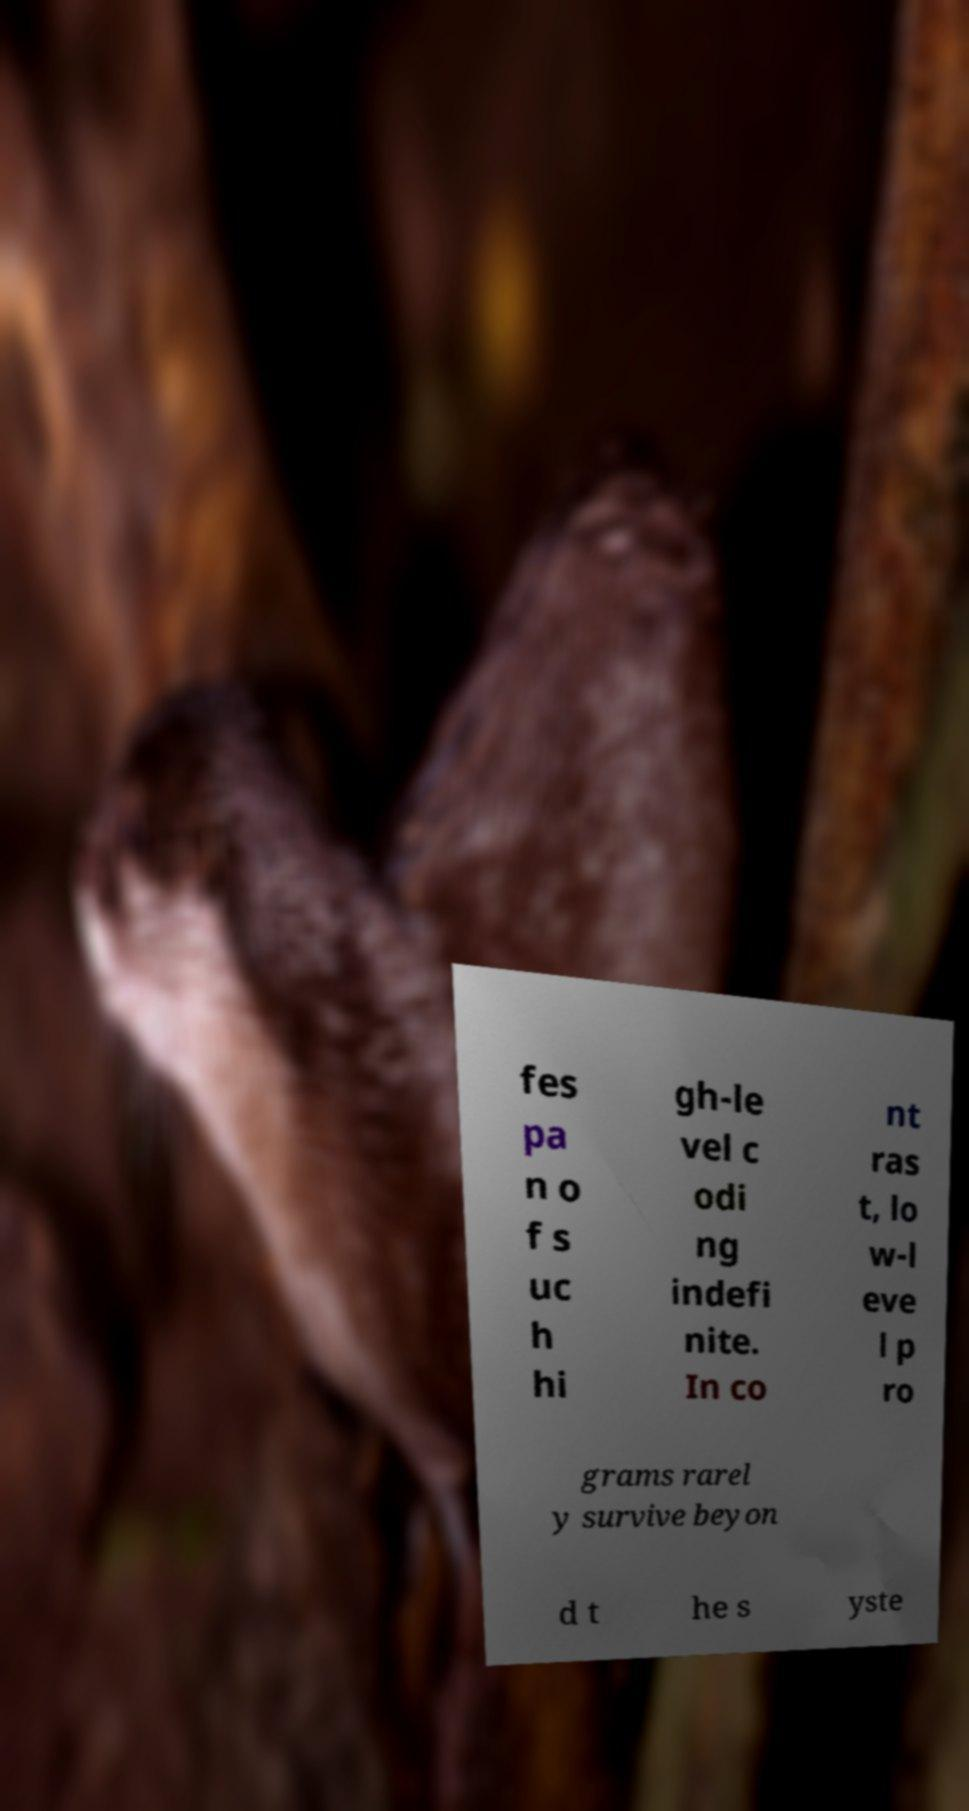There's text embedded in this image that I need extracted. Can you transcribe it verbatim? fes pa n o f s uc h hi gh-le vel c odi ng indefi nite. In co nt ras t, lo w-l eve l p ro grams rarel y survive beyon d t he s yste 